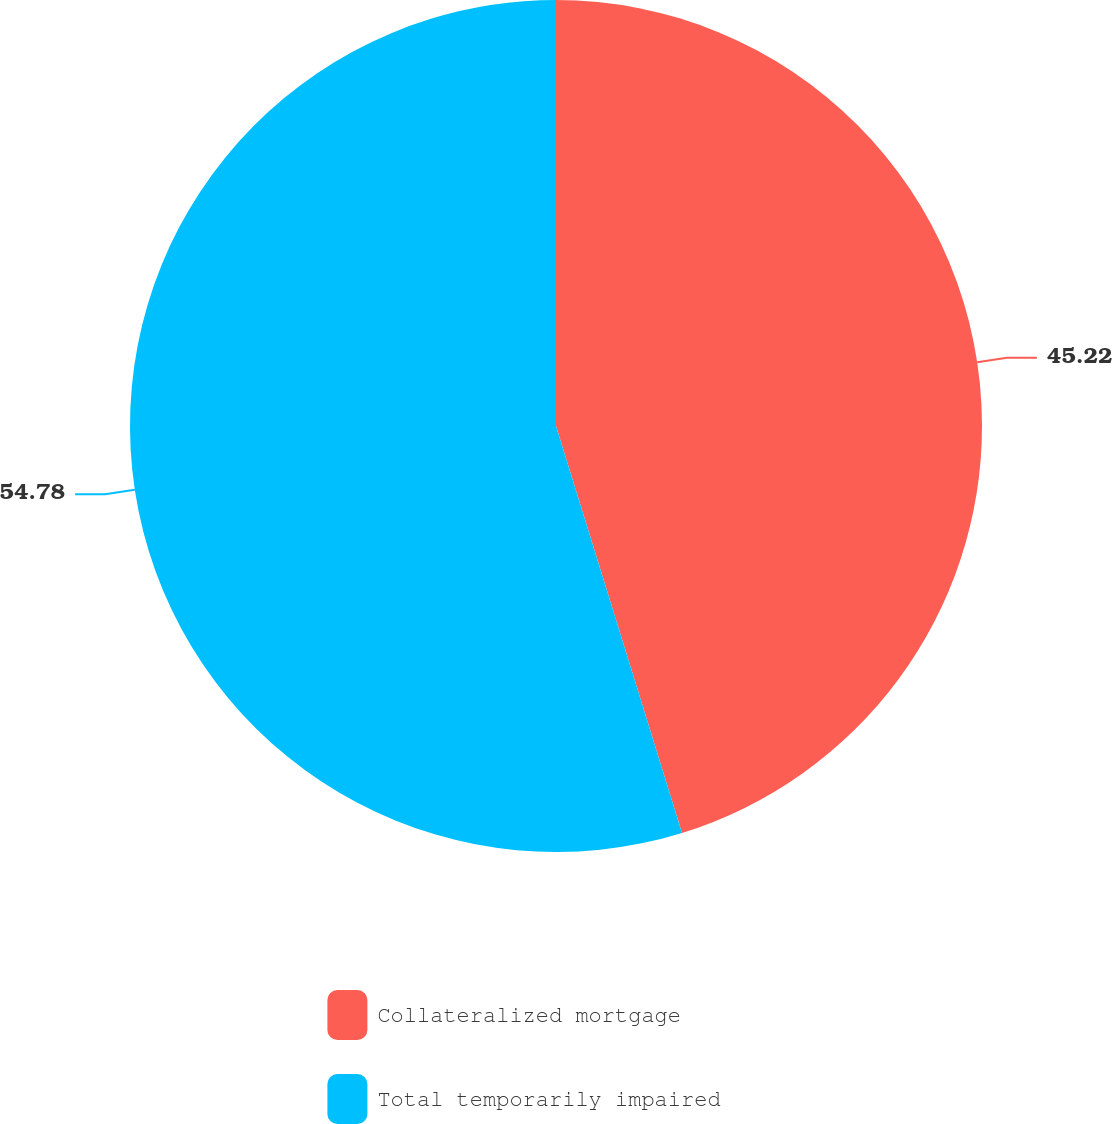Convert chart. <chart><loc_0><loc_0><loc_500><loc_500><pie_chart><fcel>Collateralized mortgage<fcel>Total temporarily impaired<nl><fcel>45.22%<fcel>54.78%<nl></chart> 